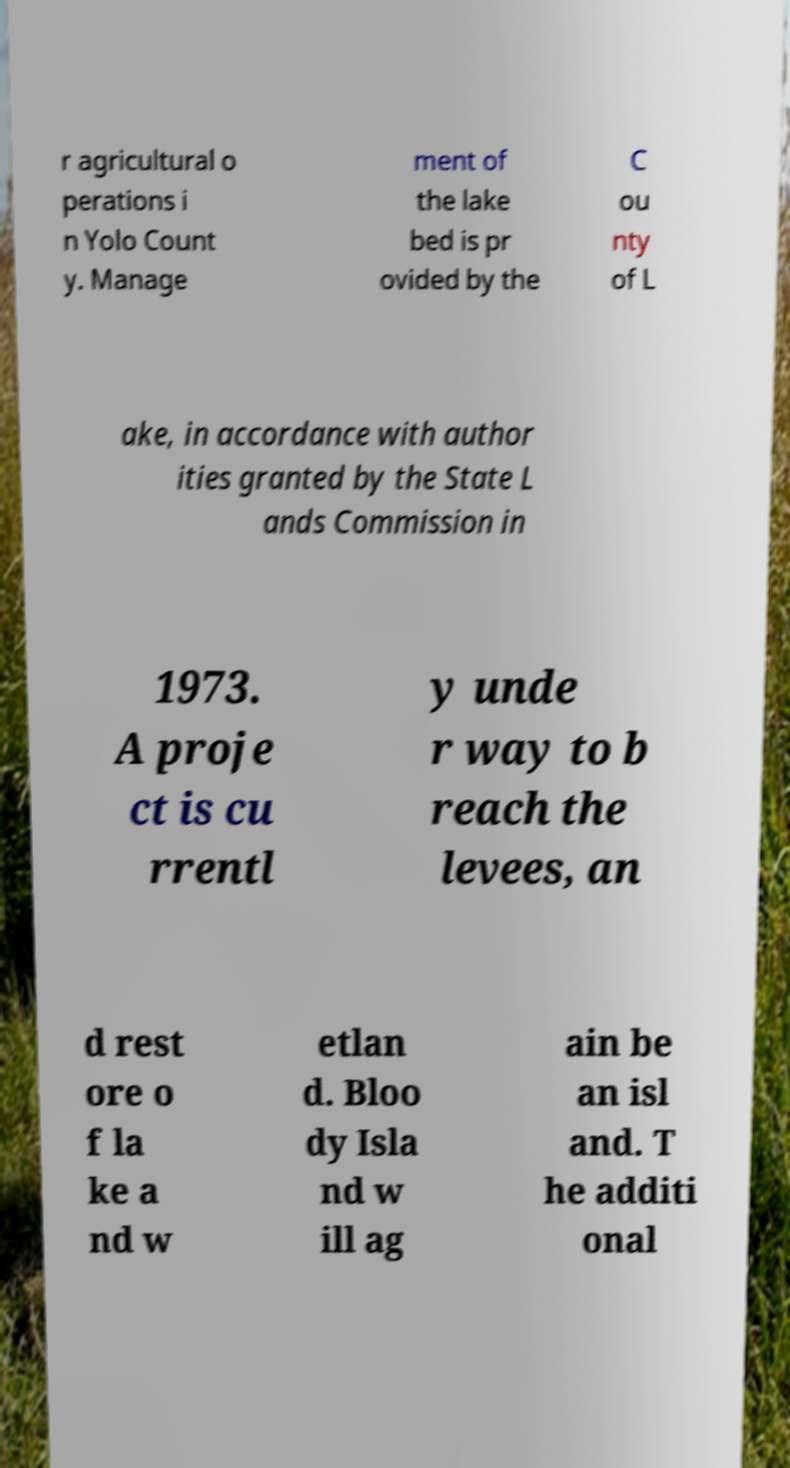Can you accurately transcribe the text from the provided image for me? r agricultural o perations i n Yolo Count y. Manage ment of the lake bed is pr ovided by the C ou nty of L ake, in accordance with author ities granted by the State L ands Commission in 1973. A proje ct is cu rrentl y unde r way to b reach the levees, an d rest ore o f la ke a nd w etlan d. Bloo dy Isla nd w ill ag ain be an isl and. T he additi onal 